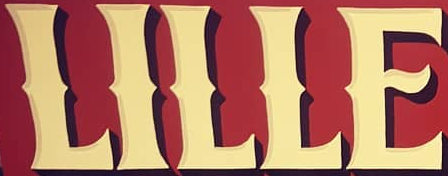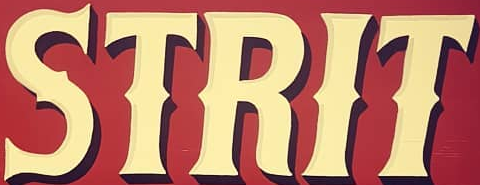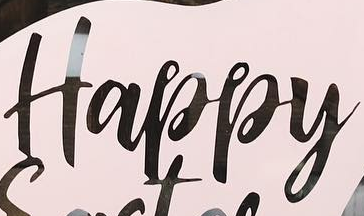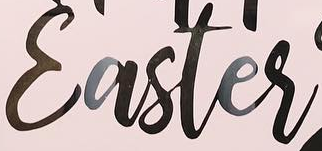What words are shown in these images in order, separated by a semicolon? LILLE; STRIT; Happy; Easter 